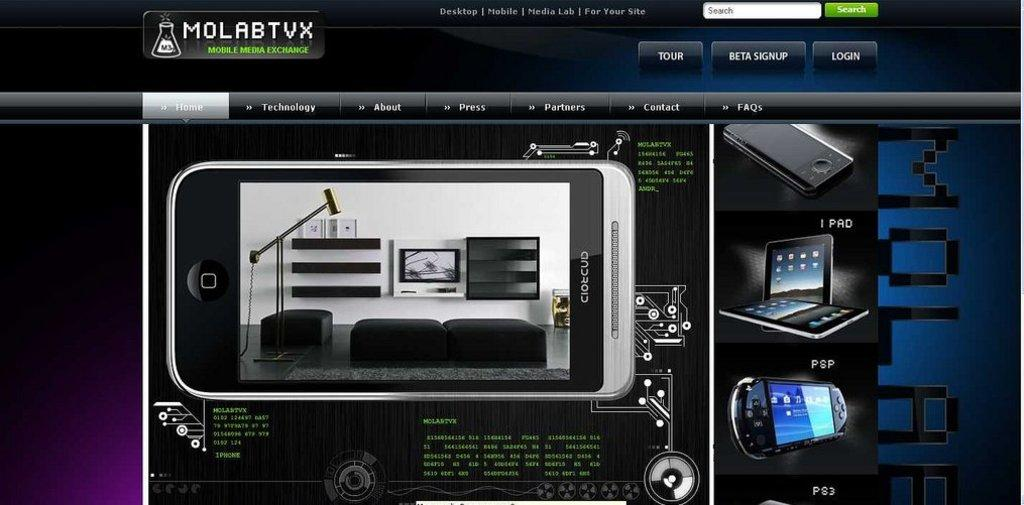<image>
Present a compact description of the photo's key features. A display screen with the program Molabtux open on the desktop 